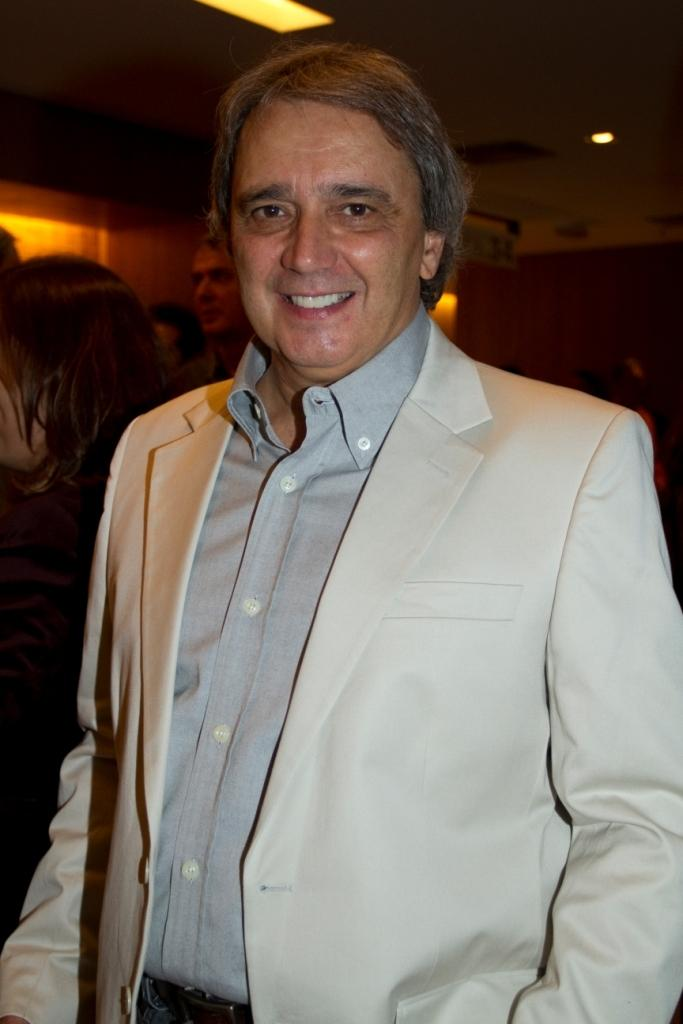What is the man in the image doing? The man is standing in the image and smiling. What is the man wearing in the image? The man is wearing a coat in the image. Can you describe the people visible in the background of the image? There are people visible in the background of the image, but their specific actions or appearances are not mentioned in the provided facts. What type of toys can be seen falling from the sky in the image? There are no toys or falling objects visible in the image; it only features a man standing and smiling, wearing a coat. 